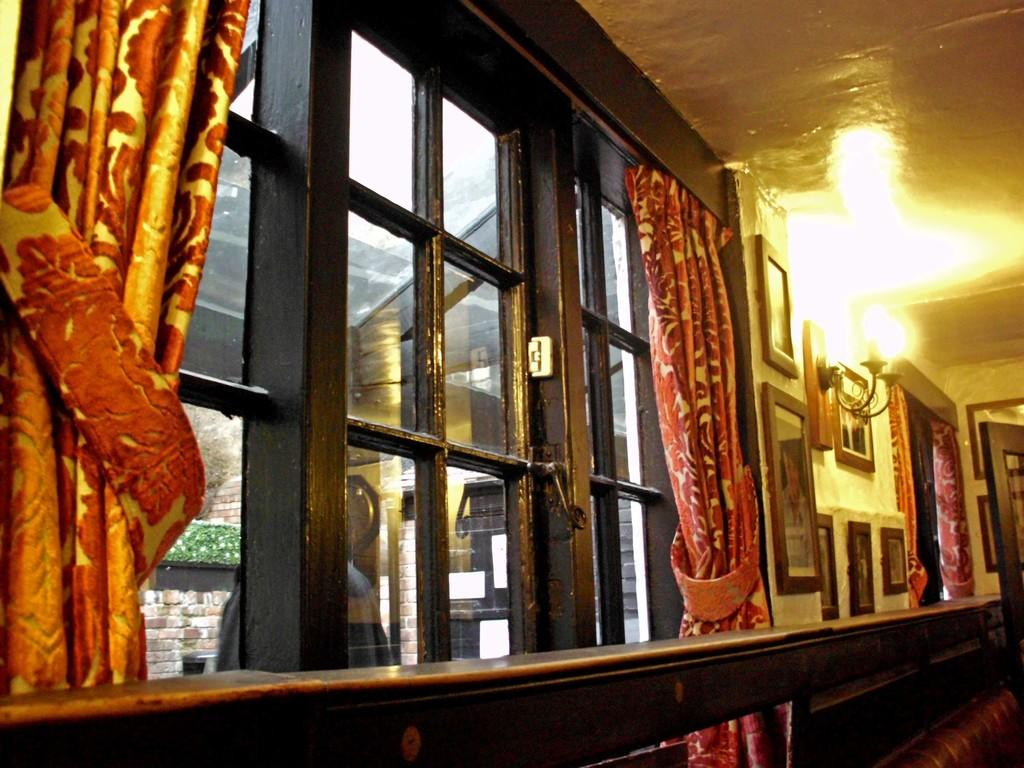What type of material is used for the railing in the image? The railing in the image is made of wood. What are the walls made of in the image? The walls in the image are not specified, but they are likely made of a solid material like brick or concrete. What can be seen through the windows in the image? The view through the windows is not specified, but it is likely a view of the outdoors or another room. What type of window treatment is present in the image? There are curtains in the image. What type of decorations are hanging on the walls in the image? There are wall hangings in the image. What type of lighting is present in the image? There are electric lights in the image. What is the structure that covers the top of the building or room in the image? There is a roof in the image. Can you see any cobwebs in the corners of the room in the image? There is no mention of cobwebs in the image, so we cannot determine if they are present or not. What type of wool is used to make the curtains in the image? There is no mention of the material used for the curtains in the image, so we cannot determine if they are made of wool or not. Is there a monkey sitting on the windowsill in the image? There is no mention of a monkey in the image, so we cannot determine if one is present or not. 